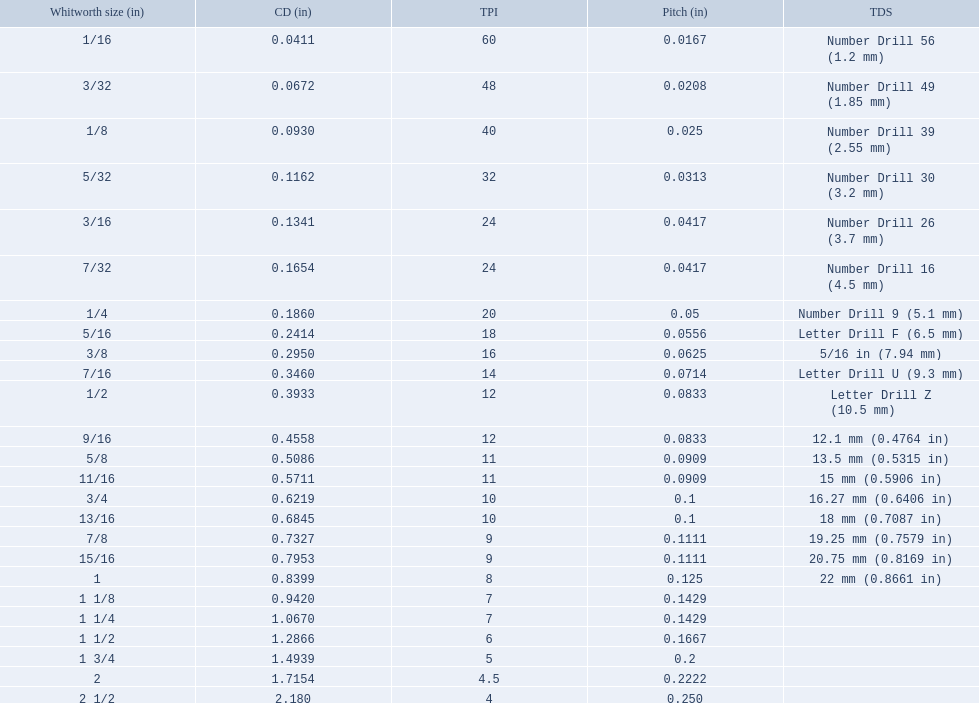What was the core diameter of a number drill 26 0.1341. What is this measurement in whitworth size? 3/16. 